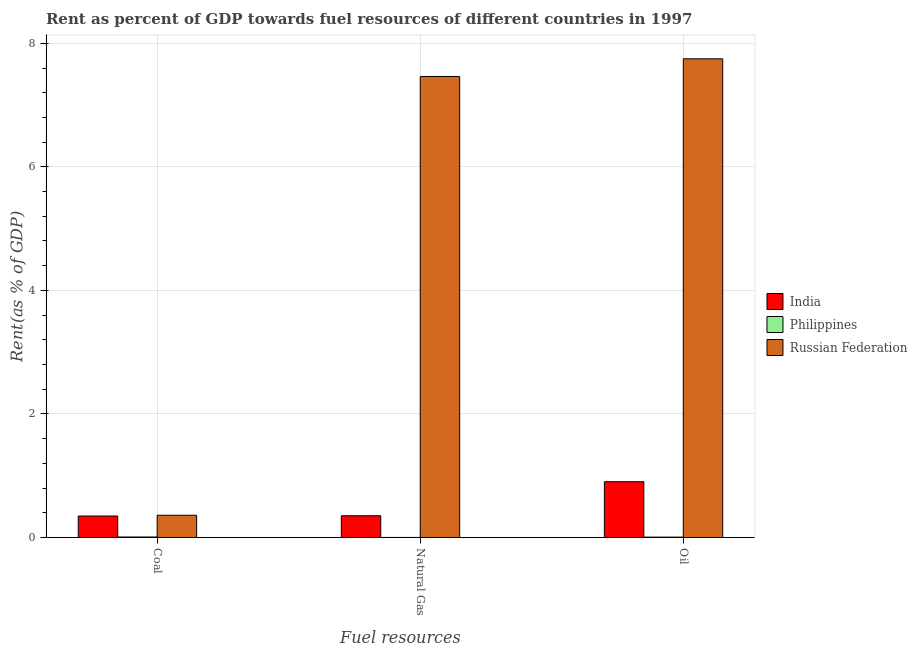Are the number of bars per tick equal to the number of legend labels?
Your answer should be compact. Yes. How many bars are there on the 3rd tick from the left?
Make the answer very short. 3. What is the label of the 3rd group of bars from the left?
Your answer should be compact. Oil. What is the rent towards natural gas in Russian Federation?
Provide a short and direct response. 7.46. Across all countries, what is the maximum rent towards oil?
Provide a succinct answer. 7.75. Across all countries, what is the minimum rent towards natural gas?
Make the answer very short. 0. In which country was the rent towards oil maximum?
Your answer should be very brief. Russian Federation. What is the total rent towards oil in the graph?
Make the answer very short. 8.66. What is the difference between the rent towards coal in Philippines and that in India?
Your answer should be very brief. -0.34. What is the difference between the rent towards coal in Philippines and the rent towards oil in Russian Federation?
Provide a short and direct response. -7.74. What is the average rent towards natural gas per country?
Ensure brevity in your answer.  2.61. What is the difference between the rent towards coal and rent towards natural gas in Russian Federation?
Ensure brevity in your answer.  -7.1. What is the ratio of the rent towards coal in Philippines to that in India?
Offer a very short reply. 0.02. What is the difference between the highest and the second highest rent towards natural gas?
Your response must be concise. 7.11. What is the difference between the highest and the lowest rent towards oil?
Offer a terse response. 7.74. Is the sum of the rent towards natural gas in Philippines and Russian Federation greater than the maximum rent towards coal across all countries?
Offer a terse response. Yes. What does the 3rd bar from the left in Natural Gas represents?
Provide a short and direct response. Russian Federation. Are all the bars in the graph horizontal?
Offer a very short reply. No. How many countries are there in the graph?
Your answer should be very brief. 3. What is the difference between two consecutive major ticks on the Y-axis?
Offer a very short reply. 2. How many legend labels are there?
Offer a terse response. 3. How are the legend labels stacked?
Offer a terse response. Vertical. What is the title of the graph?
Your answer should be compact. Rent as percent of GDP towards fuel resources of different countries in 1997. Does "Spain" appear as one of the legend labels in the graph?
Your answer should be very brief. No. What is the label or title of the X-axis?
Provide a succinct answer. Fuel resources. What is the label or title of the Y-axis?
Give a very brief answer. Rent(as % of GDP). What is the Rent(as % of GDP) in India in Coal?
Offer a terse response. 0.35. What is the Rent(as % of GDP) of Philippines in Coal?
Your answer should be very brief. 0.01. What is the Rent(as % of GDP) in Russian Federation in Coal?
Your answer should be very brief. 0.36. What is the Rent(as % of GDP) of India in Natural Gas?
Make the answer very short. 0.35. What is the Rent(as % of GDP) in Philippines in Natural Gas?
Your answer should be compact. 0. What is the Rent(as % of GDP) in Russian Federation in Natural Gas?
Make the answer very short. 7.46. What is the Rent(as % of GDP) of India in Oil?
Offer a terse response. 0.9. What is the Rent(as % of GDP) in Philippines in Oil?
Your answer should be very brief. 0.01. What is the Rent(as % of GDP) in Russian Federation in Oil?
Ensure brevity in your answer.  7.75. Across all Fuel resources, what is the maximum Rent(as % of GDP) in India?
Offer a terse response. 0.9. Across all Fuel resources, what is the maximum Rent(as % of GDP) of Philippines?
Provide a succinct answer. 0.01. Across all Fuel resources, what is the maximum Rent(as % of GDP) of Russian Federation?
Ensure brevity in your answer.  7.75. Across all Fuel resources, what is the minimum Rent(as % of GDP) of India?
Offer a terse response. 0.35. Across all Fuel resources, what is the minimum Rent(as % of GDP) in Philippines?
Offer a very short reply. 0. Across all Fuel resources, what is the minimum Rent(as % of GDP) in Russian Federation?
Make the answer very short. 0.36. What is the total Rent(as % of GDP) of India in the graph?
Your answer should be compact. 1.6. What is the total Rent(as % of GDP) in Philippines in the graph?
Give a very brief answer. 0.01. What is the total Rent(as % of GDP) of Russian Federation in the graph?
Provide a succinct answer. 15.57. What is the difference between the Rent(as % of GDP) in India in Coal and that in Natural Gas?
Provide a short and direct response. -0. What is the difference between the Rent(as % of GDP) of Philippines in Coal and that in Natural Gas?
Ensure brevity in your answer.  0.01. What is the difference between the Rent(as % of GDP) of Russian Federation in Coal and that in Natural Gas?
Your answer should be compact. -7.1. What is the difference between the Rent(as % of GDP) in India in Coal and that in Oil?
Give a very brief answer. -0.56. What is the difference between the Rent(as % of GDP) in Philippines in Coal and that in Oil?
Make the answer very short. 0. What is the difference between the Rent(as % of GDP) in Russian Federation in Coal and that in Oil?
Provide a short and direct response. -7.39. What is the difference between the Rent(as % of GDP) of India in Natural Gas and that in Oil?
Your answer should be compact. -0.55. What is the difference between the Rent(as % of GDP) of Philippines in Natural Gas and that in Oil?
Offer a terse response. -0.01. What is the difference between the Rent(as % of GDP) of Russian Federation in Natural Gas and that in Oil?
Your answer should be very brief. -0.29. What is the difference between the Rent(as % of GDP) in India in Coal and the Rent(as % of GDP) in Philippines in Natural Gas?
Provide a succinct answer. 0.35. What is the difference between the Rent(as % of GDP) in India in Coal and the Rent(as % of GDP) in Russian Federation in Natural Gas?
Your answer should be compact. -7.12. What is the difference between the Rent(as % of GDP) in Philippines in Coal and the Rent(as % of GDP) in Russian Federation in Natural Gas?
Your response must be concise. -7.46. What is the difference between the Rent(as % of GDP) in India in Coal and the Rent(as % of GDP) in Philippines in Oil?
Your answer should be compact. 0.34. What is the difference between the Rent(as % of GDP) of India in Coal and the Rent(as % of GDP) of Russian Federation in Oil?
Provide a succinct answer. -7.4. What is the difference between the Rent(as % of GDP) of Philippines in Coal and the Rent(as % of GDP) of Russian Federation in Oil?
Provide a short and direct response. -7.74. What is the difference between the Rent(as % of GDP) of India in Natural Gas and the Rent(as % of GDP) of Philippines in Oil?
Ensure brevity in your answer.  0.35. What is the difference between the Rent(as % of GDP) of India in Natural Gas and the Rent(as % of GDP) of Russian Federation in Oil?
Your answer should be compact. -7.4. What is the difference between the Rent(as % of GDP) of Philippines in Natural Gas and the Rent(as % of GDP) of Russian Federation in Oil?
Make the answer very short. -7.75. What is the average Rent(as % of GDP) in India per Fuel resources?
Offer a terse response. 0.53. What is the average Rent(as % of GDP) of Philippines per Fuel resources?
Offer a terse response. 0. What is the average Rent(as % of GDP) of Russian Federation per Fuel resources?
Offer a very short reply. 5.19. What is the difference between the Rent(as % of GDP) in India and Rent(as % of GDP) in Philippines in Coal?
Your response must be concise. 0.34. What is the difference between the Rent(as % of GDP) in India and Rent(as % of GDP) in Russian Federation in Coal?
Keep it short and to the point. -0.01. What is the difference between the Rent(as % of GDP) of Philippines and Rent(as % of GDP) of Russian Federation in Coal?
Offer a terse response. -0.35. What is the difference between the Rent(as % of GDP) in India and Rent(as % of GDP) in Philippines in Natural Gas?
Offer a very short reply. 0.35. What is the difference between the Rent(as % of GDP) of India and Rent(as % of GDP) of Russian Federation in Natural Gas?
Provide a succinct answer. -7.11. What is the difference between the Rent(as % of GDP) of Philippines and Rent(as % of GDP) of Russian Federation in Natural Gas?
Your response must be concise. -7.46. What is the difference between the Rent(as % of GDP) of India and Rent(as % of GDP) of Philippines in Oil?
Ensure brevity in your answer.  0.9. What is the difference between the Rent(as % of GDP) of India and Rent(as % of GDP) of Russian Federation in Oil?
Your response must be concise. -6.85. What is the difference between the Rent(as % of GDP) of Philippines and Rent(as % of GDP) of Russian Federation in Oil?
Your response must be concise. -7.74. What is the ratio of the Rent(as % of GDP) of India in Coal to that in Natural Gas?
Your answer should be compact. 0.99. What is the ratio of the Rent(as % of GDP) of Philippines in Coal to that in Natural Gas?
Your answer should be very brief. 15.78. What is the ratio of the Rent(as % of GDP) of Russian Federation in Coal to that in Natural Gas?
Your answer should be compact. 0.05. What is the ratio of the Rent(as % of GDP) in India in Coal to that in Oil?
Make the answer very short. 0.39. What is the ratio of the Rent(as % of GDP) of Philippines in Coal to that in Oil?
Your response must be concise. 1.32. What is the ratio of the Rent(as % of GDP) in Russian Federation in Coal to that in Oil?
Your answer should be very brief. 0.05. What is the ratio of the Rent(as % of GDP) in India in Natural Gas to that in Oil?
Offer a terse response. 0.39. What is the ratio of the Rent(as % of GDP) in Philippines in Natural Gas to that in Oil?
Your answer should be compact. 0.08. What is the ratio of the Rent(as % of GDP) in Russian Federation in Natural Gas to that in Oil?
Give a very brief answer. 0.96. What is the difference between the highest and the second highest Rent(as % of GDP) in India?
Give a very brief answer. 0.55. What is the difference between the highest and the second highest Rent(as % of GDP) of Philippines?
Your answer should be compact. 0. What is the difference between the highest and the second highest Rent(as % of GDP) in Russian Federation?
Keep it short and to the point. 0.29. What is the difference between the highest and the lowest Rent(as % of GDP) in India?
Your answer should be very brief. 0.56. What is the difference between the highest and the lowest Rent(as % of GDP) of Philippines?
Ensure brevity in your answer.  0.01. What is the difference between the highest and the lowest Rent(as % of GDP) in Russian Federation?
Provide a succinct answer. 7.39. 